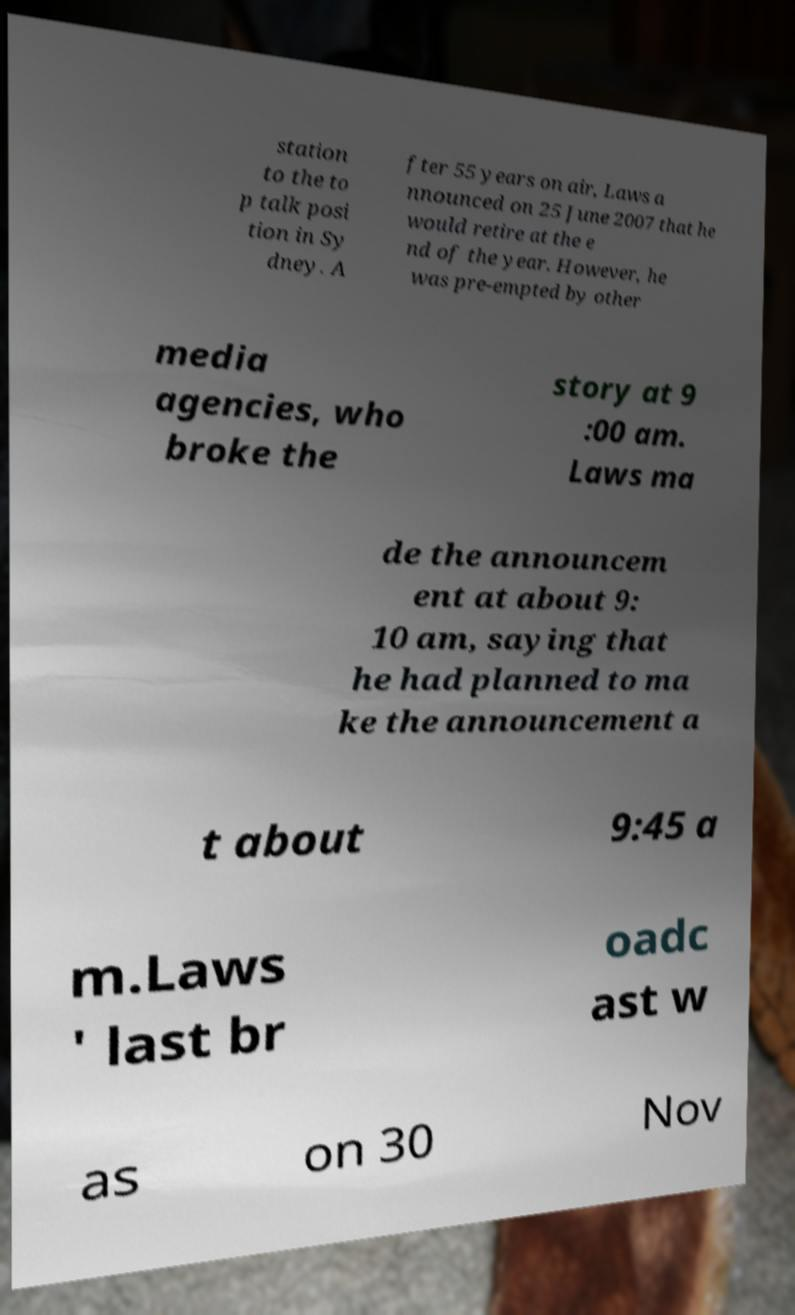Could you extract and type out the text from this image? station to the to p talk posi tion in Sy dney. A fter 55 years on air, Laws a nnounced on 25 June 2007 that he would retire at the e nd of the year. However, he was pre-empted by other media agencies, who broke the story at 9 :00 am. Laws ma de the announcem ent at about 9: 10 am, saying that he had planned to ma ke the announcement a t about 9:45 a m.Laws ' last br oadc ast w as on 30 Nov 